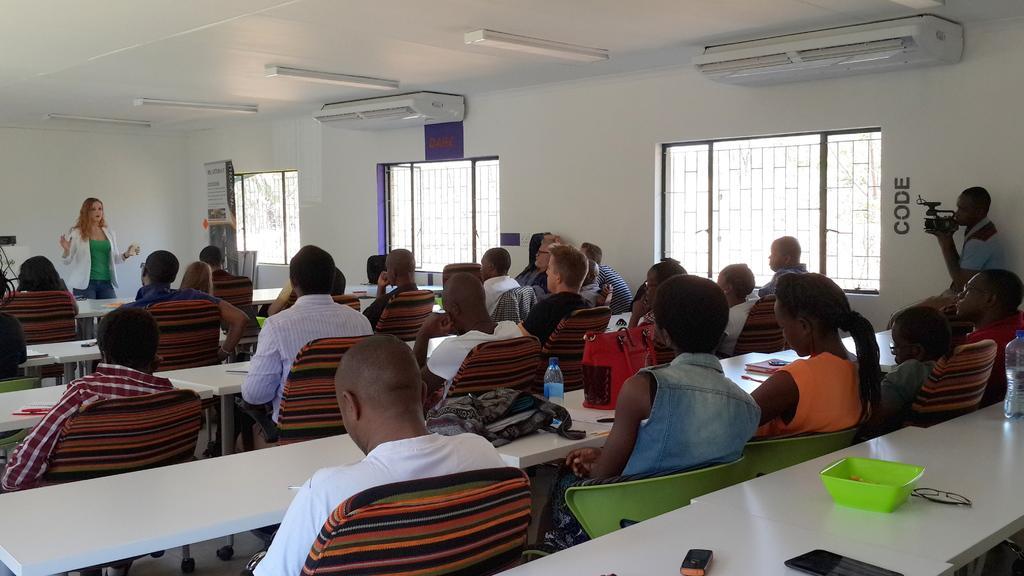In one or two sentences, can you explain what this image depicts? The picture is taken in a closed room where people are sitting on the chairs and in front of them there is table on which bags, water bottles, books, bowls, glasses, mobiles are kept and in front of them one woman in green shirt and white coat is standing and behind her there is a wall and beside them there are windows and there are ac's in the room and at the right corner one man is standing and holding a camera in his hands. 